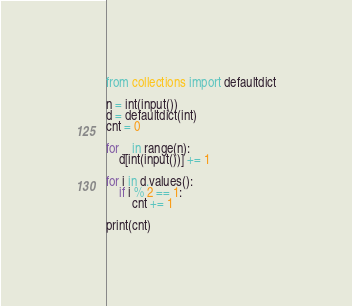Convert code to text. <code><loc_0><loc_0><loc_500><loc_500><_Python_>from collections import defaultdict

n = int(input())
d = defaultdict(int)
cnt = 0

for _ in range(n):
    d[int(input())] += 1

for i in d.values():
    if i % 2 == 1:
        cnt += 1

print(cnt)
</code> 